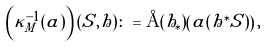Convert formula to latex. <formula><loc_0><loc_0><loc_500><loc_500>\left ( \kappa _ { M } ^ { - 1 } ( a ) \right ) ( S , h ) \colon = \AA ( h _ { \ast } ) \left ( a ( h ^ { \ast } S ) \right ) ,</formula> 